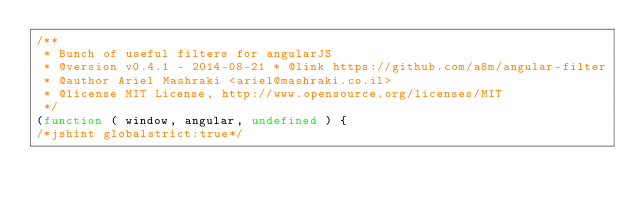Convert code to text. <code><loc_0><loc_0><loc_500><loc_500><_JavaScript_>/**
 * Bunch of useful filters for angularJS
 * @version v0.4.1 - 2014-08-21 * @link https://github.com/a8m/angular-filter
 * @author Ariel Mashraki <ariel@mashraki.co.il>
 * @license MIT License, http://www.opensource.org/licenses/MIT
 */
(function ( window, angular, undefined ) {
/*jshint globalstrict:true*/</code> 